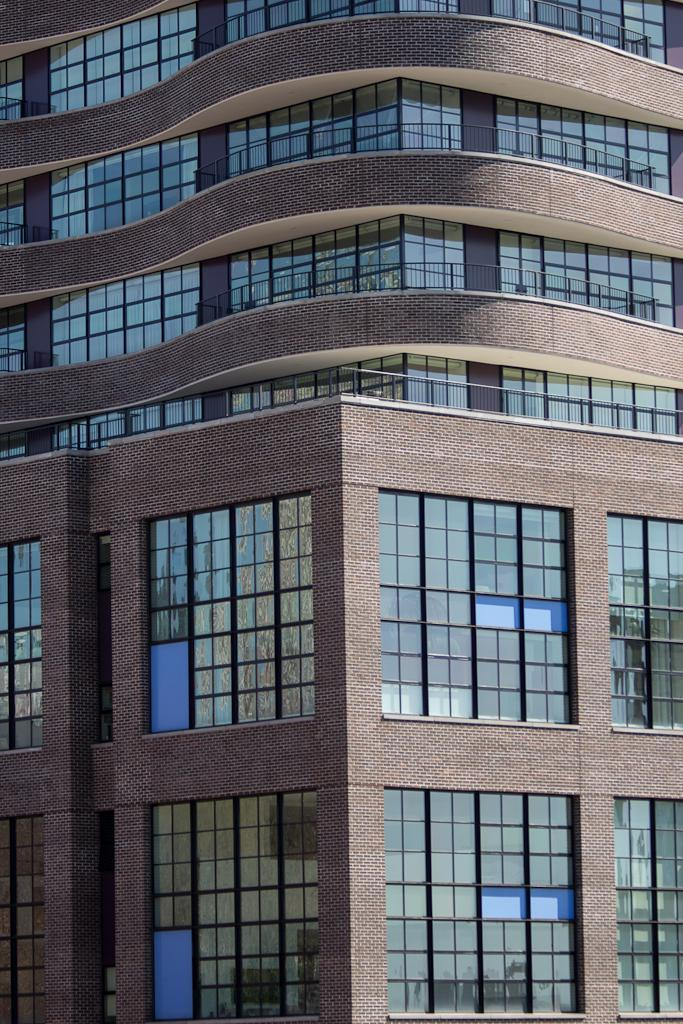What type of structure is visible in the image? There is a building in the image. What type of window treatment is present in the image? There are curtains in the image. What type of brass instrument is being played in the image? There is no brass instrument or any musical instrument present in the image. 